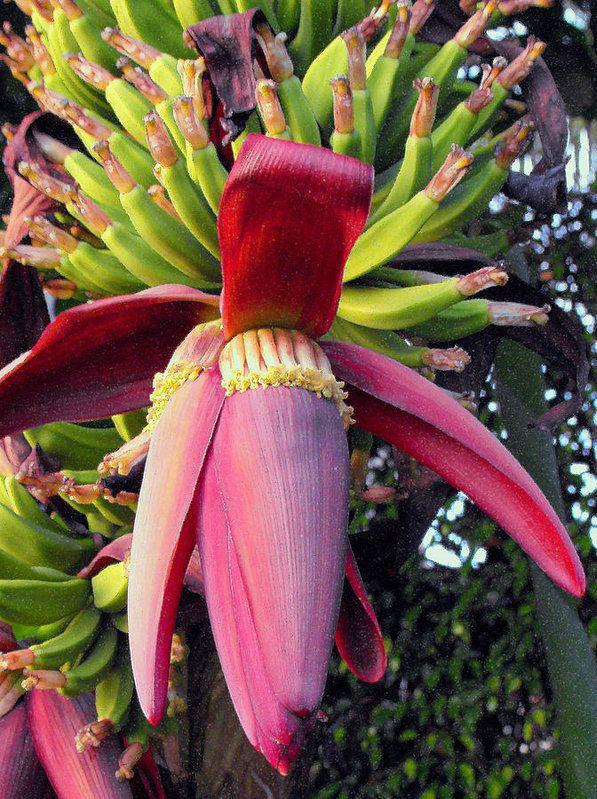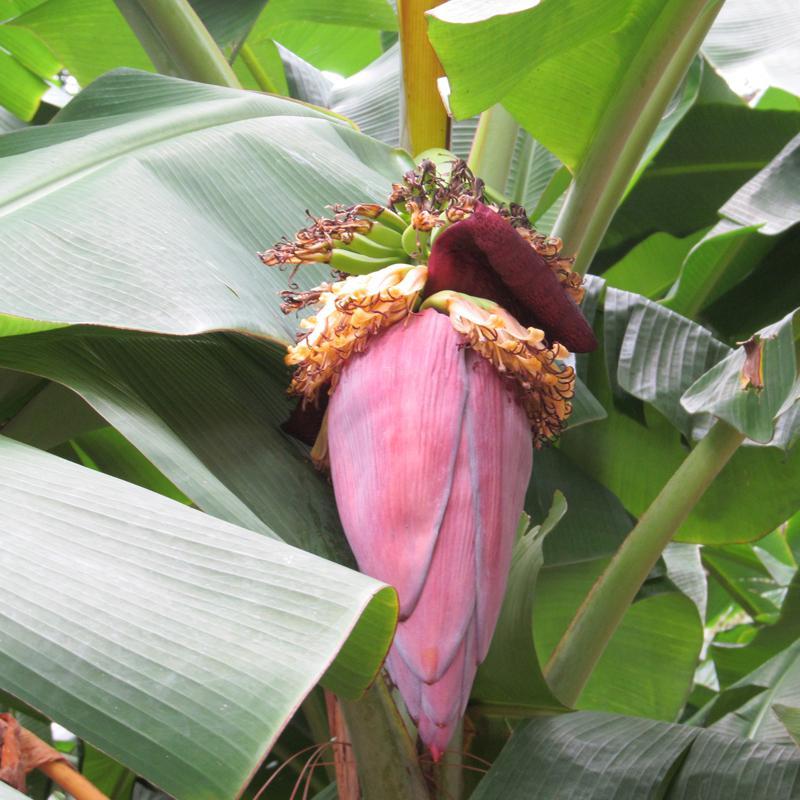The first image is the image on the left, the second image is the image on the right. For the images shown, is this caption "Each image shows a large purplish flower beneath bunches of green bananas, but no image shows a flower with more than three petals fanning out." true? Answer yes or no. No. 